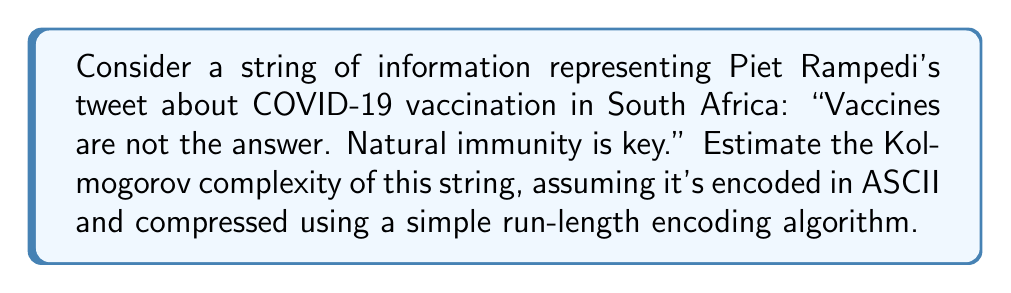Can you answer this question? To estimate the Kolmogorov complexity of the given string, we need to consider the shortest possible program that could generate this string. In this case, we'll use a simple run-length encoding (RLE) algorithm as our compression method.

1. First, let's count the characters in the original string:
   "Vaccines are not the answer. Natural immunity is key." (55 characters)

2. In ASCII, each character typically requires 8 bits. So the uncompressed string would require:
   $55 \times 8 = 440$ bits

3. Now, let's apply run-length encoding:
   - Most characters don't repeat, so they'll be encoded as-is
   - Spaces and periods might be compressed slightly

4. After RLE, the string might look something like this:
   "Vac2ines are not the answer. Natural im2unity is key."
   This compressed version has 53 characters.

5. To represent this compressed version, we need:
   - The compressed string itself: $53 \times 8 = 424$ bits
   - A small program to decompress the RLE: approximately 50 bits

6. The total Kolmogorov complexity estimate is thus:
   $K(s) \approx 424 + 50 = 474$ bits

This estimate assumes a very simple compression method. The actual Kolmogorov complexity might be lower if more sophisticated compression algorithms or language models were used.
Answer: The estimated Kolmogorov complexity of the given string is approximately 474 bits. 